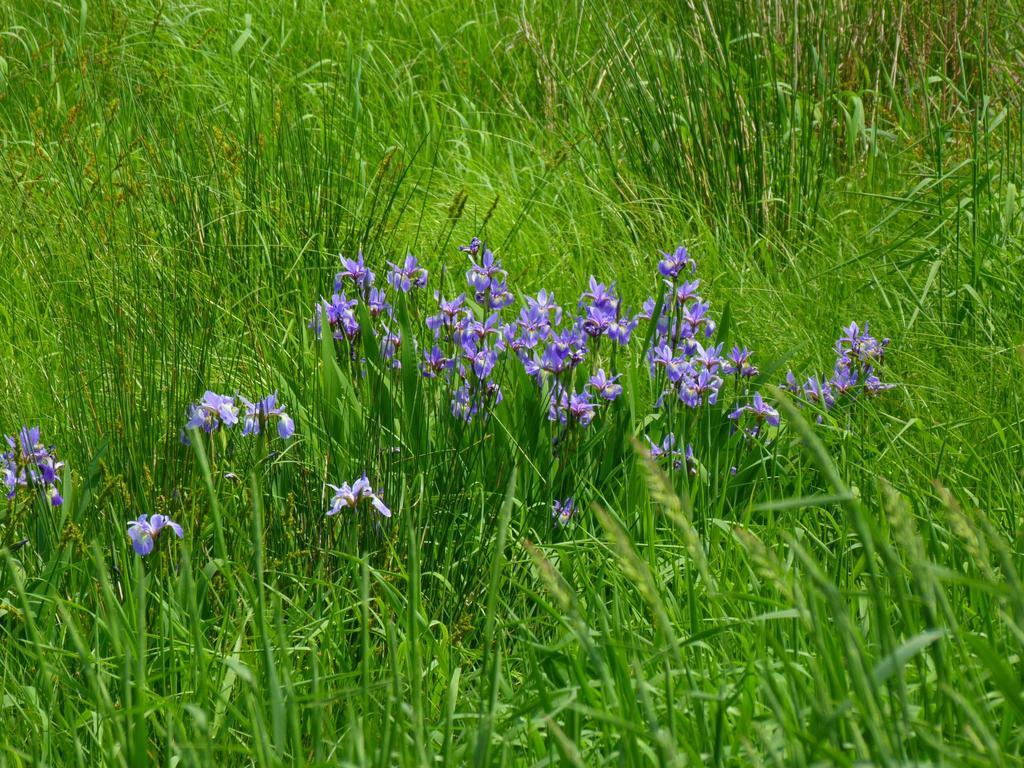What type of plants can be seen in the image? There are flower plants in the image. What type of vegetation is visible in the image besides the flower plants? The grass is visible in the image. What color are the flowers in the image? The flowers are purple in color. What type of machine can be seen in the image? There is no machine present in the image; it features flower plants and grass. How many business cards are visible in the image? There are no business cards or any business-related items present in the image. 